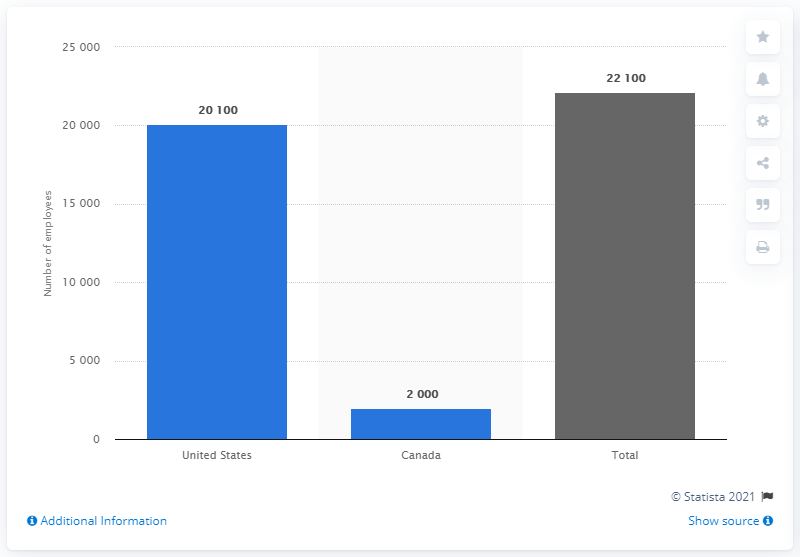Specify some key components in this picture. As of 2021, the number of employees in Canada is approximately 2000. 